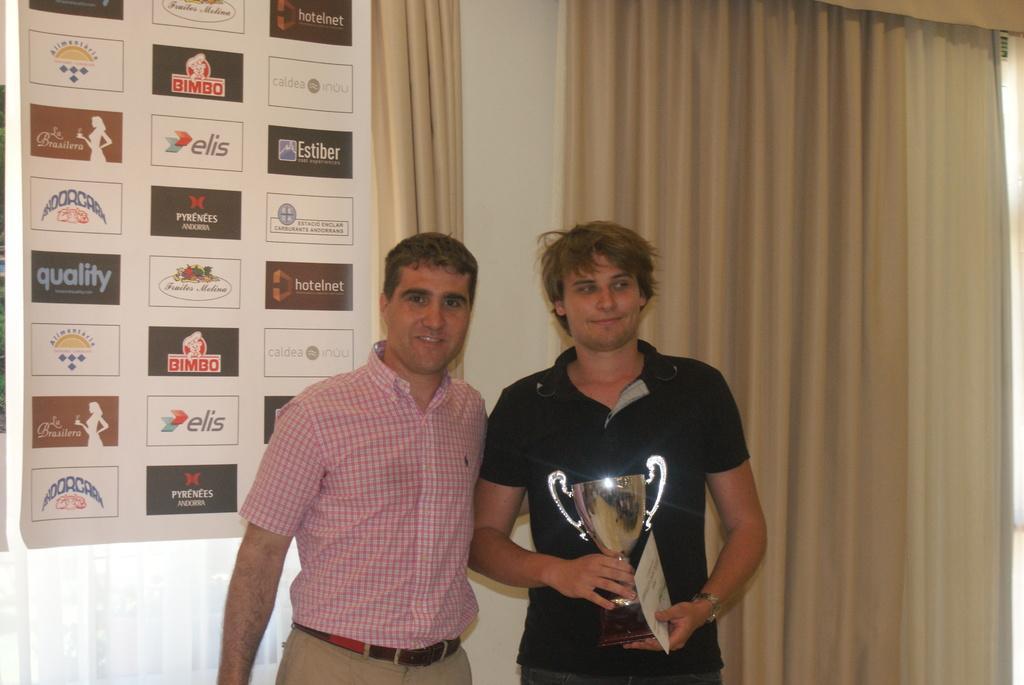Could you give a brief overview of what you see in this image? In this picture I can see couple of men standing and I can see a man standing and holding a memento and a certificate in his hands and I can see a banner with some text and few logos. I can see curtains in the back. 